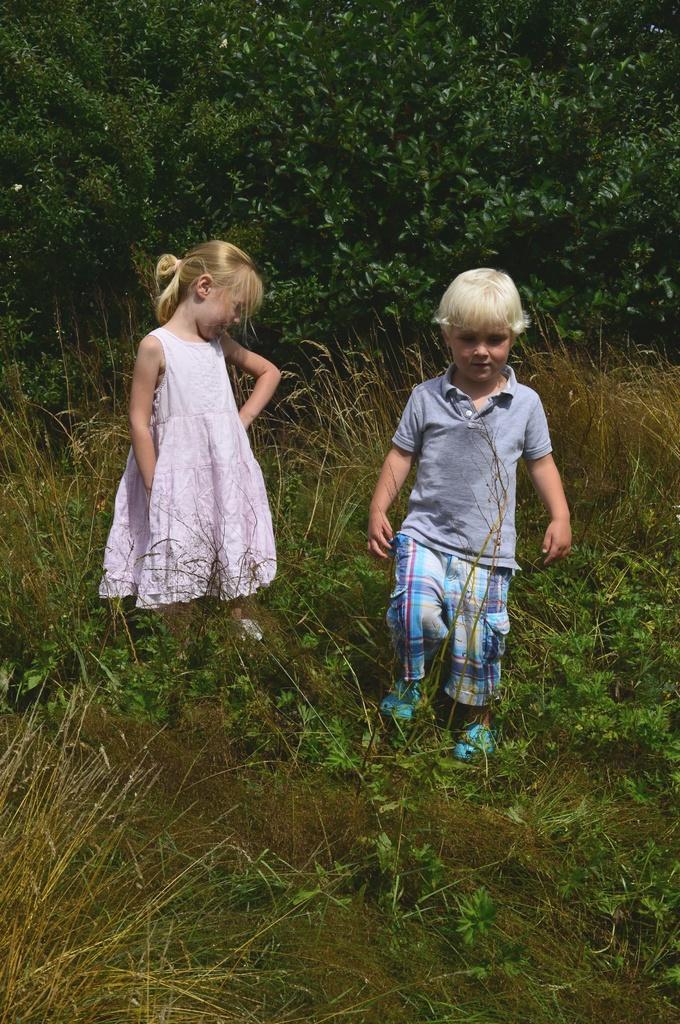In one or two sentences, can you explain what this image depicts? In this image there are two kids on a grassland, in the background there are trees. 